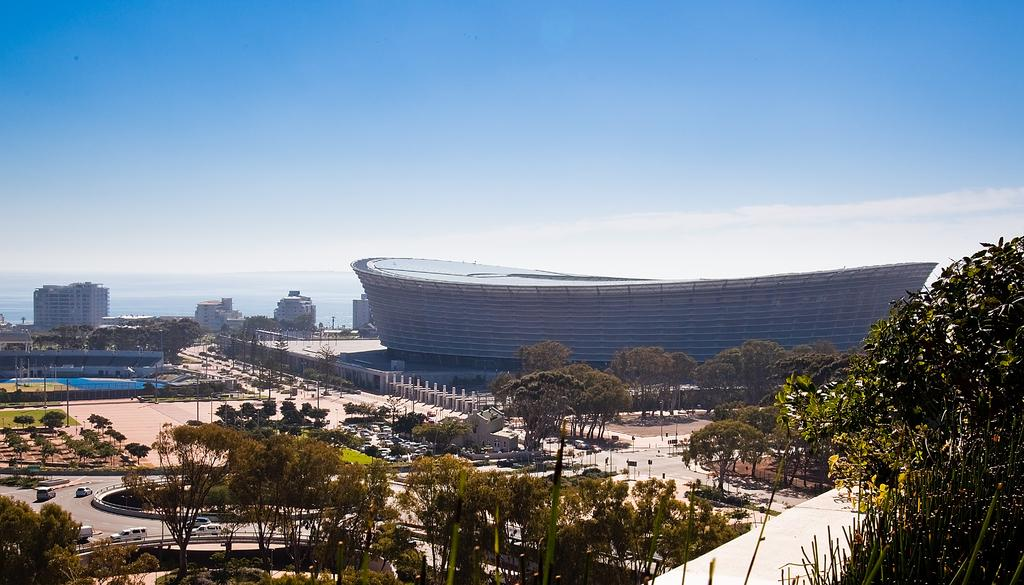What type of vegetation can be seen at the bottom of the image? There are trees at the bottom of the image. What is present on the road in the image? There are vehicles on the road in the image. What can be seen in the background of the image? There are buildings, glass doors, water, trees, and clouds in the sky in the background of the image. What type of tooth is visible in the image? There is no tooth present in the image. What scientific theory can be observed in the image? There is no scientific theory depicted in the image. 